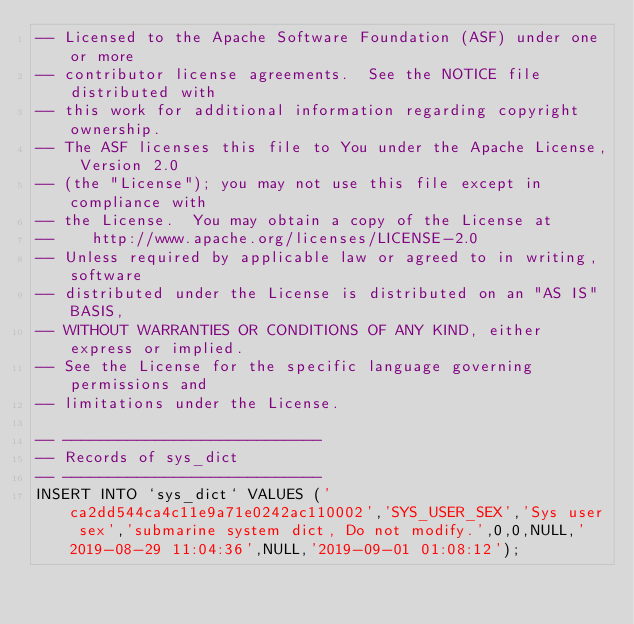Convert code to text. <code><loc_0><loc_0><loc_500><loc_500><_SQL_>-- Licensed to the Apache Software Foundation (ASF) under one or more
-- contributor license agreements.  See the NOTICE file distributed with
-- this work for additional information regarding copyright ownership.
-- The ASF licenses this file to You under the Apache License, Version 2.0
-- (the "License"); you may not use this file except in compliance with
-- the License.  You may obtain a copy of the License at
--    http://www.apache.org/licenses/LICENSE-2.0
-- Unless required by applicable law or agreed to in writing, software
-- distributed under the License is distributed on an "AS IS" BASIS,
-- WITHOUT WARRANTIES OR CONDITIONS OF ANY KIND, either express or implied.
-- See the License for the specific language governing permissions and
-- limitations under the License.

-- ----------------------------
-- Records of sys_dict
-- ----------------------------
INSERT INTO `sys_dict` VALUES ('ca2dd544ca4c11e9a71e0242ac110002','SYS_USER_SEX','Sys user sex','submarine system dict, Do not modify.',0,0,NULL,'2019-08-29 11:04:36',NULL,'2019-09-01 01:08:12');</code> 